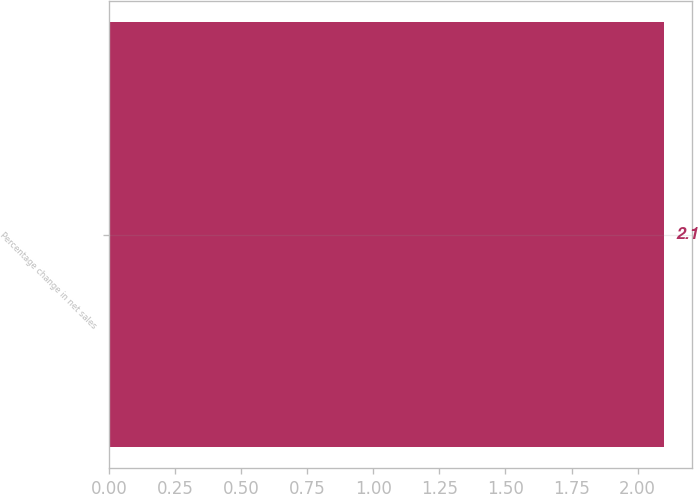Convert chart to OTSL. <chart><loc_0><loc_0><loc_500><loc_500><bar_chart><fcel>Percentage change in net sales<nl><fcel>2.1<nl></chart> 